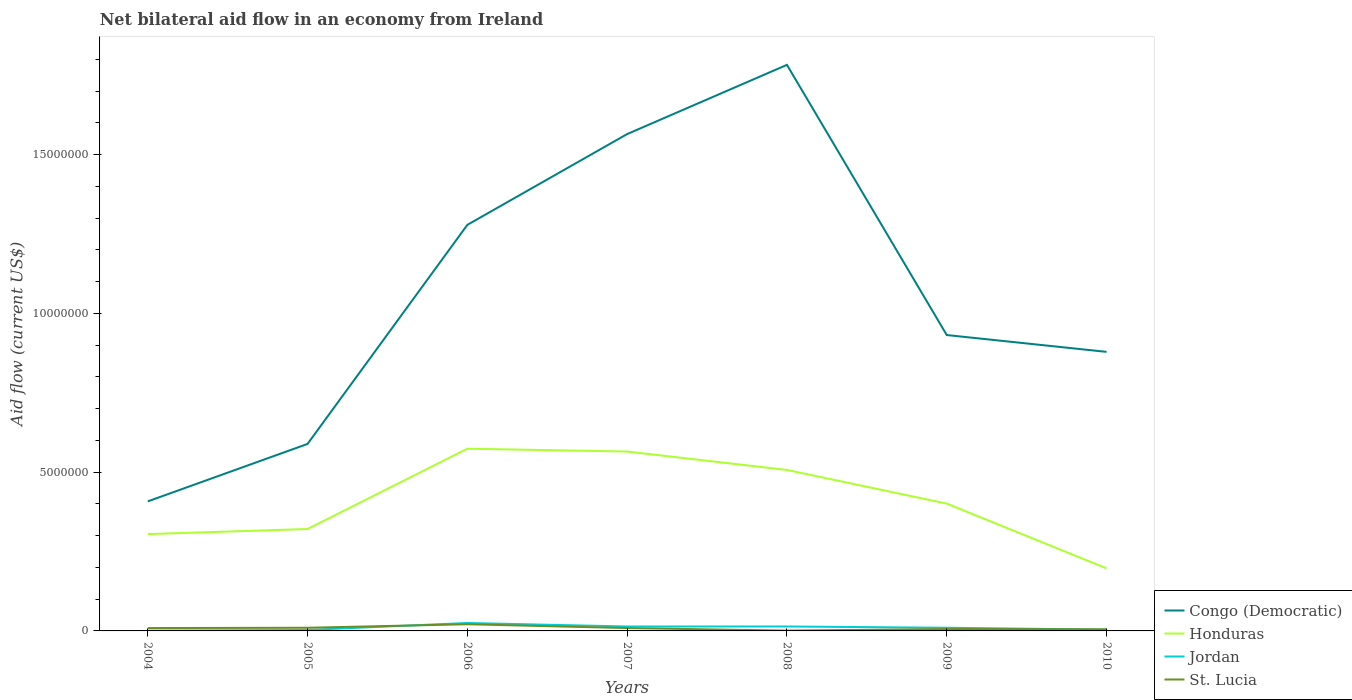Is the number of lines equal to the number of legend labels?
Keep it short and to the point. Yes. Across all years, what is the maximum net bilateral aid flow in Congo (Democratic)?
Provide a short and direct response. 4.08e+06. In which year was the net bilateral aid flow in Congo (Democratic) maximum?
Offer a very short reply. 2004. Is the net bilateral aid flow in Congo (Democratic) strictly greater than the net bilateral aid flow in St. Lucia over the years?
Your answer should be very brief. No. How many lines are there?
Make the answer very short. 4. What is the difference between two consecutive major ticks on the Y-axis?
Provide a short and direct response. 5.00e+06. Does the graph contain any zero values?
Offer a very short reply. No. Does the graph contain grids?
Provide a succinct answer. No. What is the title of the graph?
Keep it short and to the point. Net bilateral aid flow in an economy from Ireland. What is the label or title of the X-axis?
Keep it short and to the point. Years. What is the label or title of the Y-axis?
Offer a very short reply. Aid flow (current US$). What is the Aid flow (current US$) of Congo (Democratic) in 2004?
Make the answer very short. 4.08e+06. What is the Aid flow (current US$) in Honduras in 2004?
Your answer should be compact. 3.05e+06. What is the Aid flow (current US$) of Jordan in 2004?
Your response must be concise. 10000. What is the Aid flow (current US$) in St. Lucia in 2004?
Keep it short and to the point. 9.00e+04. What is the Aid flow (current US$) in Congo (Democratic) in 2005?
Ensure brevity in your answer.  5.89e+06. What is the Aid flow (current US$) of Honduras in 2005?
Keep it short and to the point. 3.21e+06. What is the Aid flow (current US$) in Jordan in 2005?
Provide a short and direct response. 3.00e+04. What is the Aid flow (current US$) of St. Lucia in 2005?
Ensure brevity in your answer.  1.00e+05. What is the Aid flow (current US$) in Congo (Democratic) in 2006?
Offer a very short reply. 1.28e+07. What is the Aid flow (current US$) in Honduras in 2006?
Keep it short and to the point. 5.74e+06. What is the Aid flow (current US$) of St. Lucia in 2006?
Provide a short and direct response. 2.10e+05. What is the Aid flow (current US$) in Congo (Democratic) in 2007?
Offer a very short reply. 1.56e+07. What is the Aid flow (current US$) in Honduras in 2007?
Provide a short and direct response. 5.65e+06. What is the Aid flow (current US$) in Congo (Democratic) in 2008?
Offer a terse response. 1.78e+07. What is the Aid flow (current US$) of Honduras in 2008?
Your response must be concise. 5.07e+06. What is the Aid flow (current US$) of Jordan in 2008?
Your answer should be very brief. 1.40e+05. What is the Aid flow (current US$) in St. Lucia in 2008?
Offer a very short reply. 10000. What is the Aid flow (current US$) of Congo (Democratic) in 2009?
Give a very brief answer. 9.32e+06. What is the Aid flow (current US$) in Honduras in 2009?
Offer a very short reply. 4.01e+06. What is the Aid flow (current US$) of Congo (Democratic) in 2010?
Ensure brevity in your answer.  8.79e+06. What is the Aid flow (current US$) of Honduras in 2010?
Your answer should be compact. 1.97e+06. What is the Aid flow (current US$) of St. Lucia in 2010?
Offer a terse response. 5.00e+04. Across all years, what is the maximum Aid flow (current US$) of Congo (Democratic)?
Ensure brevity in your answer.  1.78e+07. Across all years, what is the maximum Aid flow (current US$) of Honduras?
Ensure brevity in your answer.  5.74e+06. Across all years, what is the minimum Aid flow (current US$) in Congo (Democratic)?
Provide a succinct answer. 4.08e+06. Across all years, what is the minimum Aid flow (current US$) of Honduras?
Offer a terse response. 1.97e+06. Across all years, what is the minimum Aid flow (current US$) in Jordan?
Make the answer very short. 10000. Across all years, what is the minimum Aid flow (current US$) in St. Lucia?
Provide a succinct answer. 10000. What is the total Aid flow (current US$) in Congo (Democratic) in the graph?
Make the answer very short. 7.44e+07. What is the total Aid flow (current US$) of Honduras in the graph?
Give a very brief answer. 2.87e+07. What is the total Aid flow (current US$) of Jordan in the graph?
Your answer should be very brief. 7.10e+05. What is the total Aid flow (current US$) of St. Lucia in the graph?
Your answer should be compact. 6.10e+05. What is the difference between the Aid flow (current US$) of Congo (Democratic) in 2004 and that in 2005?
Give a very brief answer. -1.81e+06. What is the difference between the Aid flow (current US$) of Jordan in 2004 and that in 2005?
Your answer should be very brief. -2.00e+04. What is the difference between the Aid flow (current US$) in St. Lucia in 2004 and that in 2005?
Make the answer very short. -10000. What is the difference between the Aid flow (current US$) in Congo (Democratic) in 2004 and that in 2006?
Keep it short and to the point. -8.71e+06. What is the difference between the Aid flow (current US$) of Honduras in 2004 and that in 2006?
Offer a terse response. -2.69e+06. What is the difference between the Aid flow (current US$) of Jordan in 2004 and that in 2006?
Offer a terse response. -2.40e+05. What is the difference between the Aid flow (current US$) in Congo (Democratic) in 2004 and that in 2007?
Make the answer very short. -1.16e+07. What is the difference between the Aid flow (current US$) in Honduras in 2004 and that in 2007?
Offer a terse response. -2.60e+06. What is the difference between the Aid flow (current US$) in Jordan in 2004 and that in 2007?
Make the answer very short. -1.30e+05. What is the difference between the Aid flow (current US$) of Congo (Democratic) in 2004 and that in 2008?
Provide a succinct answer. -1.38e+07. What is the difference between the Aid flow (current US$) of Honduras in 2004 and that in 2008?
Provide a short and direct response. -2.02e+06. What is the difference between the Aid flow (current US$) in Jordan in 2004 and that in 2008?
Your answer should be very brief. -1.30e+05. What is the difference between the Aid flow (current US$) of St. Lucia in 2004 and that in 2008?
Your answer should be very brief. 8.00e+04. What is the difference between the Aid flow (current US$) in Congo (Democratic) in 2004 and that in 2009?
Ensure brevity in your answer.  -5.24e+06. What is the difference between the Aid flow (current US$) of Honduras in 2004 and that in 2009?
Your answer should be compact. -9.60e+05. What is the difference between the Aid flow (current US$) of Congo (Democratic) in 2004 and that in 2010?
Offer a terse response. -4.71e+06. What is the difference between the Aid flow (current US$) in Honduras in 2004 and that in 2010?
Offer a terse response. 1.08e+06. What is the difference between the Aid flow (current US$) of Congo (Democratic) in 2005 and that in 2006?
Your answer should be very brief. -6.90e+06. What is the difference between the Aid flow (current US$) in Honduras in 2005 and that in 2006?
Ensure brevity in your answer.  -2.53e+06. What is the difference between the Aid flow (current US$) in Congo (Democratic) in 2005 and that in 2007?
Offer a terse response. -9.76e+06. What is the difference between the Aid flow (current US$) of Honduras in 2005 and that in 2007?
Your answer should be compact. -2.44e+06. What is the difference between the Aid flow (current US$) in St. Lucia in 2005 and that in 2007?
Your response must be concise. 10000. What is the difference between the Aid flow (current US$) of Congo (Democratic) in 2005 and that in 2008?
Provide a succinct answer. -1.19e+07. What is the difference between the Aid flow (current US$) of Honduras in 2005 and that in 2008?
Give a very brief answer. -1.86e+06. What is the difference between the Aid flow (current US$) of Congo (Democratic) in 2005 and that in 2009?
Provide a succinct answer. -3.43e+06. What is the difference between the Aid flow (current US$) in Honduras in 2005 and that in 2009?
Ensure brevity in your answer.  -8.00e+05. What is the difference between the Aid flow (current US$) of Jordan in 2005 and that in 2009?
Provide a short and direct response. -7.00e+04. What is the difference between the Aid flow (current US$) of Congo (Democratic) in 2005 and that in 2010?
Your response must be concise. -2.90e+06. What is the difference between the Aid flow (current US$) of Honduras in 2005 and that in 2010?
Keep it short and to the point. 1.24e+06. What is the difference between the Aid flow (current US$) in Jordan in 2005 and that in 2010?
Make the answer very short. -10000. What is the difference between the Aid flow (current US$) of St. Lucia in 2005 and that in 2010?
Offer a very short reply. 5.00e+04. What is the difference between the Aid flow (current US$) of Congo (Democratic) in 2006 and that in 2007?
Your answer should be compact. -2.86e+06. What is the difference between the Aid flow (current US$) of Honduras in 2006 and that in 2007?
Your response must be concise. 9.00e+04. What is the difference between the Aid flow (current US$) in St. Lucia in 2006 and that in 2007?
Ensure brevity in your answer.  1.20e+05. What is the difference between the Aid flow (current US$) of Congo (Democratic) in 2006 and that in 2008?
Your answer should be very brief. -5.04e+06. What is the difference between the Aid flow (current US$) in Honduras in 2006 and that in 2008?
Offer a terse response. 6.70e+05. What is the difference between the Aid flow (current US$) in Congo (Democratic) in 2006 and that in 2009?
Your response must be concise. 3.47e+06. What is the difference between the Aid flow (current US$) in Honduras in 2006 and that in 2009?
Offer a very short reply. 1.73e+06. What is the difference between the Aid flow (current US$) in Honduras in 2006 and that in 2010?
Ensure brevity in your answer.  3.77e+06. What is the difference between the Aid flow (current US$) in Jordan in 2006 and that in 2010?
Your answer should be very brief. 2.10e+05. What is the difference between the Aid flow (current US$) in Congo (Democratic) in 2007 and that in 2008?
Offer a very short reply. -2.18e+06. What is the difference between the Aid flow (current US$) of Honduras in 2007 and that in 2008?
Ensure brevity in your answer.  5.80e+05. What is the difference between the Aid flow (current US$) in St. Lucia in 2007 and that in 2008?
Your answer should be compact. 8.00e+04. What is the difference between the Aid flow (current US$) of Congo (Democratic) in 2007 and that in 2009?
Your response must be concise. 6.33e+06. What is the difference between the Aid flow (current US$) in Honduras in 2007 and that in 2009?
Offer a very short reply. 1.64e+06. What is the difference between the Aid flow (current US$) of St. Lucia in 2007 and that in 2009?
Your answer should be compact. 3.00e+04. What is the difference between the Aid flow (current US$) of Congo (Democratic) in 2007 and that in 2010?
Offer a very short reply. 6.86e+06. What is the difference between the Aid flow (current US$) of Honduras in 2007 and that in 2010?
Offer a very short reply. 3.68e+06. What is the difference between the Aid flow (current US$) of Congo (Democratic) in 2008 and that in 2009?
Your answer should be very brief. 8.51e+06. What is the difference between the Aid flow (current US$) in Honduras in 2008 and that in 2009?
Give a very brief answer. 1.06e+06. What is the difference between the Aid flow (current US$) of Congo (Democratic) in 2008 and that in 2010?
Provide a succinct answer. 9.04e+06. What is the difference between the Aid flow (current US$) in Honduras in 2008 and that in 2010?
Give a very brief answer. 3.10e+06. What is the difference between the Aid flow (current US$) in Jordan in 2008 and that in 2010?
Your answer should be very brief. 1.00e+05. What is the difference between the Aid flow (current US$) in St. Lucia in 2008 and that in 2010?
Provide a succinct answer. -4.00e+04. What is the difference between the Aid flow (current US$) in Congo (Democratic) in 2009 and that in 2010?
Offer a terse response. 5.30e+05. What is the difference between the Aid flow (current US$) in Honduras in 2009 and that in 2010?
Provide a short and direct response. 2.04e+06. What is the difference between the Aid flow (current US$) of Jordan in 2009 and that in 2010?
Offer a very short reply. 6.00e+04. What is the difference between the Aid flow (current US$) of St. Lucia in 2009 and that in 2010?
Keep it short and to the point. 10000. What is the difference between the Aid flow (current US$) of Congo (Democratic) in 2004 and the Aid flow (current US$) of Honduras in 2005?
Ensure brevity in your answer.  8.70e+05. What is the difference between the Aid flow (current US$) of Congo (Democratic) in 2004 and the Aid flow (current US$) of Jordan in 2005?
Your answer should be very brief. 4.05e+06. What is the difference between the Aid flow (current US$) of Congo (Democratic) in 2004 and the Aid flow (current US$) of St. Lucia in 2005?
Your answer should be compact. 3.98e+06. What is the difference between the Aid flow (current US$) of Honduras in 2004 and the Aid flow (current US$) of Jordan in 2005?
Offer a very short reply. 3.02e+06. What is the difference between the Aid flow (current US$) in Honduras in 2004 and the Aid flow (current US$) in St. Lucia in 2005?
Offer a very short reply. 2.95e+06. What is the difference between the Aid flow (current US$) of Congo (Democratic) in 2004 and the Aid flow (current US$) of Honduras in 2006?
Your answer should be very brief. -1.66e+06. What is the difference between the Aid flow (current US$) of Congo (Democratic) in 2004 and the Aid flow (current US$) of Jordan in 2006?
Ensure brevity in your answer.  3.83e+06. What is the difference between the Aid flow (current US$) in Congo (Democratic) in 2004 and the Aid flow (current US$) in St. Lucia in 2006?
Provide a succinct answer. 3.87e+06. What is the difference between the Aid flow (current US$) in Honduras in 2004 and the Aid flow (current US$) in Jordan in 2006?
Offer a very short reply. 2.80e+06. What is the difference between the Aid flow (current US$) in Honduras in 2004 and the Aid flow (current US$) in St. Lucia in 2006?
Your answer should be very brief. 2.84e+06. What is the difference between the Aid flow (current US$) in Jordan in 2004 and the Aid flow (current US$) in St. Lucia in 2006?
Ensure brevity in your answer.  -2.00e+05. What is the difference between the Aid flow (current US$) of Congo (Democratic) in 2004 and the Aid flow (current US$) of Honduras in 2007?
Your answer should be very brief. -1.57e+06. What is the difference between the Aid flow (current US$) in Congo (Democratic) in 2004 and the Aid flow (current US$) in Jordan in 2007?
Ensure brevity in your answer.  3.94e+06. What is the difference between the Aid flow (current US$) in Congo (Democratic) in 2004 and the Aid flow (current US$) in St. Lucia in 2007?
Provide a short and direct response. 3.99e+06. What is the difference between the Aid flow (current US$) of Honduras in 2004 and the Aid flow (current US$) of Jordan in 2007?
Your response must be concise. 2.91e+06. What is the difference between the Aid flow (current US$) of Honduras in 2004 and the Aid flow (current US$) of St. Lucia in 2007?
Give a very brief answer. 2.96e+06. What is the difference between the Aid flow (current US$) in Congo (Democratic) in 2004 and the Aid flow (current US$) in Honduras in 2008?
Ensure brevity in your answer.  -9.90e+05. What is the difference between the Aid flow (current US$) of Congo (Democratic) in 2004 and the Aid flow (current US$) of Jordan in 2008?
Your answer should be very brief. 3.94e+06. What is the difference between the Aid flow (current US$) of Congo (Democratic) in 2004 and the Aid flow (current US$) of St. Lucia in 2008?
Provide a short and direct response. 4.07e+06. What is the difference between the Aid flow (current US$) of Honduras in 2004 and the Aid flow (current US$) of Jordan in 2008?
Make the answer very short. 2.91e+06. What is the difference between the Aid flow (current US$) of Honduras in 2004 and the Aid flow (current US$) of St. Lucia in 2008?
Ensure brevity in your answer.  3.04e+06. What is the difference between the Aid flow (current US$) in Jordan in 2004 and the Aid flow (current US$) in St. Lucia in 2008?
Provide a succinct answer. 0. What is the difference between the Aid flow (current US$) in Congo (Democratic) in 2004 and the Aid flow (current US$) in Jordan in 2009?
Make the answer very short. 3.98e+06. What is the difference between the Aid flow (current US$) in Congo (Democratic) in 2004 and the Aid flow (current US$) in St. Lucia in 2009?
Provide a succinct answer. 4.02e+06. What is the difference between the Aid flow (current US$) in Honduras in 2004 and the Aid flow (current US$) in Jordan in 2009?
Offer a very short reply. 2.95e+06. What is the difference between the Aid flow (current US$) in Honduras in 2004 and the Aid flow (current US$) in St. Lucia in 2009?
Provide a short and direct response. 2.99e+06. What is the difference between the Aid flow (current US$) of Jordan in 2004 and the Aid flow (current US$) of St. Lucia in 2009?
Make the answer very short. -5.00e+04. What is the difference between the Aid flow (current US$) of Congo (Democratic) in 2004 and the Aid flow (current US$) of Honduras in 2010?
Ensure brevity in your answer.  2.11e+06. What is the difference between the Aid flow (current US$) of Congo (Democratic) in 2004 and the Aid flow (current US$) of Jordan in 2010?
Your response must be concise. 4.04e+06. What is the difference between the Aid flow (current US$) in Congo (Democratic) in 2004 and the Aid flow (current US$) in St. Lucia in 2010?
Offer a terse response. 4.03e+06. What is the difference between the Aid flow (current US$) in Honduras in 2004 and the Aid flow (current US$) in Jordan in 2010?
Ensure brevity in your answer.  3.01e+06. What is the difference between the Aid flow (current US$) in Honduras in 2004 and the Aid flow (current US$) in St. Lucia in 2010?
Your answer should be compact. 3.00e+06. What is the difference between the Aid flow (current US$) of Congo (Democratic) in 2005 and the Aid flow (current US$) of Jordan in 2006?
Your response must be concise. 5.64e+06. What is the difference between the Aid flow (current US$) of Congo (Democratic) in 2005 and the Aid flow (current US$) of St. Lucia in 2006?
Keep it short and to the point. 5.68e+06. What is the difference between the Aid flow (current US$) of Honduras in 2005 and the Aid flow (current US$) of Jordan in 2006?
Offer a terse response. 2.96e+06. What is the difference between the Aid flow (current US$) in Honduras in 2005 and the Aid flow (current US$) in St. Lucia in 2006?
Keep it short and to the point. 3.00e+06. What is the difference between the Aid flow (current US$) of Jordan in 2005 and the Aid flow (current US$) of St. Lucia in 2006?
Provide a succinct answer. -1.80e+05. What is the difference between the Aid flow (current US$) of Congo (Democratic) in 2005 and the Aid flow (current US$) of Honduras in 2007?
Provide a succinct answer. 2.40e+05. What is the difference between the Aid flow (current US$) in Congo (Democratic) in 2005 and the Aid flow (current US$) in Jordan in 2007?
Offer a terse response. 5.75e+06. What is the difference between the Aid flow (current US$) in Congo (Democratic) in 2005 and the Aid flow (current US$) in St. Lucia in 2007?
Offer a very short reply. 5.80e+06. What is the difference between the Aid flow (current US$) in Honduras in 2005 and the Aid flow (current US$) in Jordan in 2007?
Make the answer very short. 3.07e+06. What is the difference between the Aid flow (current US$) in Honduras in 2005 and the Aid flow (current US$) in St. Lucia in 2007?
Make the answer very short. 3.12e+06. What is the difference between the Aid flow (current US$) of Congo (Democratic) in 2005 and the Aid flow (current US$) of Honduras in 2008?
Provide a succinct answer. 8.20e+05. What is the difference between the Aid flow (current US$) of Congo (Democratic) in 2005 and the Aid flow (current US$) of Jordan in 2008?
Your answer should be very brief. 5.75e+06. What is the difference between the Aid flow (current US$) of Congo (Democratic) in 2005 and the Aid flow (current US$) of St. Lucia in 2008?
Give a very brief answer. 5.88e+06. What is the difference between the Aid flow (current US$) of Honduras in 2005 and the Aid flow (current US$) of Jordan in 2008?
Your answer should be very brief. 3.07e+06. What is the difference between the Aid flow (current US$) in Honduras in 2005 and the Aid flow (current US$) in St. Lucia in 2008?
Provide a succinct answer. 3.20e+06. What is the difference between the Aid flow (current US$) of Congo (Democratic) in 2005 and the Aid flow (current US$) of Honduras in 2009?
Provide a succinct answer. 1.88e+06. What is the difference between the Aid flow (current US$) of Congo (Democratic) in 2005 and the Aid flow (current US$) of Jordan in 2009?
Your answer should be compact. 5.79e+06. What is the difference between the Aid flow (current US$) of Congo (Democratic) in 2005 and the Aid flow (current US$) of St. Lucia in 2009?
Offer a very short reply. 5.83e+06. What is the difference between the Aid flow (current US$) of Honduras in 2005 and the Aid flow (current US$) of Jordan in 2009?
Provide a succinct answer. 3.11e+06. What is the difference between the Aid flow (current US$) of Honduras in 2005 and the Aid flow (current US$) of St. Lucia in 2009?
Give a very brief answer. 3.15e+06. What is the difference between the Aid flow (current US$) of Congo (Democratic) in 2005 and the Aid flow (current US$) of Honduras in 2010?
Your answer should be very brief. 3.92e+06. What is the difference between the Aid flow (current US$) in Congo (Democratic) in 2005 and the Aid flow (current US$) in Jordan in 2010?
Make the answer very short. 5.85e+06. What is the difference between the Aid flow (current US$) of Congo (Democratic) in 2005 and the Aid flow (current US$) of St. Lucia in 2010?
Your response must be concise. 5.84e+06. What is the difference between the Aid flow (current US$) of Honduras in 2005 and the Aid flow (current US$) of Jordan in 2010?
Your answer should be very brief. 3.17e+06. What is the difference between the Aid flow (current US$) in Honduras in 2005 and the Aid flow (current US$) in St. Lucia in 2010?
Give a very brief answer. 3.16e+06. What is the difference between the Aid flow (current US$) in Congo (Democratic) in 2006 and the Aid flow (current US$) in Honduras in 2007?
Give a very brief answer. 7.14e+06. What is the difference between the Aid flow (current US$) of Congo (Democratic) in 2006 and the Aid flow (current US$) of Jordan in 2007?
Make the answer very short. 1.26e+07. What is the difference between the Aid flow (current US$) in Congo (Democratic) in 2006 and the Aid flow (current US$) in St. Lucia in 2007?
Keep it short and to the point. 1.27e+07. What is the difference between the Aid flow (current US$) in Honduras in 2006 and the Aid flow (current US$) in Jordan in 2007?
Keep it short and to the point. 5.60e+06. What is the difference between the Aid flow (current US$) in Honduras in 2006 and the Aid flow (current US$) in St. Lucia in 2007?
Your response must be concise. 5.65e+06. What is the difference between the Aid flow (current US$) in Congo (Democratic) in 2006 and the Aid flow (current US$) in Honduras in 2008?
Provide a short and direct response. 7.72e+06. What is the difference between the Aid flow (current US$) of Congo (Democratic) in 2006 and the Aid flow (current US$) of Jordan in 2008?
Your answer should be very brief. 1.26e+07. What is the difference between the Aid flow (current US$) of Congo (Democratic) in 2006 and the Aid flow (current US$) of St. Lucia in 2008?
Your response must be concise. 1.28e+07. What is the difference between the Aid flow (current US$) of Honduras in 2006 and the Aid flow (current US$) of Jordan in 2008?
Your response must be concise. 5.60e+06. What is the difference between the Aid flow (current US$) of Honduras in 2006 and the Aid flow (current US$) of St. Lucia in 2008?
Ensure brevity in your answer.  5.73e+06. What is the difference between the Aid flow (current US$) in Congo (Democratic) in 2006 and the Aid flow (current US$) in Honduras in 2009?
Your answer should be compact. 8.78e+06. What is the difference between the Aid flow (current US$) of Congo (Democratic) in 2006 and the Aid flow (current US$) of Jordan in 2009?
Provide a succinct answer. 1.27e+07. What is the difference between the Aid flow (current US$) in Congo (Democratic) in 2006 and the Aid flow (current US$) in St. Lucia in 2009?
Offer a very short reply. 1.27e+07. What is the difference between the Aid flow (current US$) of Honduras in 2006 and the Aid flow (current US$) of Jordan in 2009?
Provide a succinct answer. 5.64e+06. What is the difference between the Aid flow (current US$) in Honduras in 2006 and the Aid flow (current US$) in St. Lucia in 2009?
Keep it short and to the point. 5.68e+06. What is the difference between the Aid flow (current US$) of Jordan in 2006 and the Aid flow (current US$) of St. Lucia in 2009?
Offer a very short reply. 1.90e+05. What is the difference between the Aid flow (current US$) in Congo (Democratic) in 2006 and the Aid flow (current US$) in Honduras in 2010?
Make the answer very short. 1.08e+07. What is the difference between the Aid flow (current US$) of Congo (Democratic) in 2006 and the Aid flow (current US$) of Jordan in 2010?
Make the answer very short. 1.28e+07. What is the difference between the Aid flow (current US$) in Congo (Democratic) in 2006 and the Aid flow (current US$) in St. Lucia in 2010?
Your response must be concise. 1.27e+07. What is the difference between the Aid flow (current US$) of Honduras in 2006 and the Aid flow (current US$) of Jordan in 2010?
Your answer should be compact. 5.70e+06. What is the difference between the Aid flow (current US$) of Honduras in 2006 and the Aid flow (current US$) of St. Lucia in 2010?
Keep it short and to the point. 5.69e+06. What is the difference between the Aid flow (current US$) in Congo (Democratic) in 2007 and the Aid flow (current US$) in Honduras in 2008?
Provide a succinct answer. 1.06e+07. What is the difference between the Aid flow (current US$) in Congo (Democratic) in 2007 and the Aid flow (current US$) in Jordan in 2008?
Give a very brief answer. 1.55e+07. What is the difference between the Aid flow (current US$) of Congo (Democratic) in 2007 and the Aid flow (current US$) of St. Lucia in 2008?
Make the answer very short. 1.56e+07. What is the difference between the Aid flow (current US$) of Honduras in 2007 and the Aid flow (current US$) of Jordan in 2008?
Provide a succinct answer. 5.51e+06. What is the difference between the Aid flow (current US$) in Honduras in 2007 and the Aid flow (current US$) in St. Lucia in 2008?
Provide a short and direct response. 5.64e+06. What is the difference between the Aid flow (current US$) in Congo (Democratic) in 2007 and the Aid flow (current US$) in Honduras in 2009?
Your response must be concise. 1.16e+07. What is the difference between the Aid flow (current US$) in Congo (Democratic) in 2007 and the Aid flow (current US$) in Jordan in 2009?
Offer a very short reply. 1.56e+07. What is the difference between the Aid flow (current US$) of Congo (Democratic) in 2007 and the Aid flow (current US$) of St. Lucia in 2009?
Your answer should be compact. 1.56e+07. What is the difference between the Aid flow (current US$) in Honduras in 2007 and the Aid flow (current US$) in Jordan in 2009?
Keep it short and to the point. 5.55e+06. What is the difference between the Aid flow (current US$) in Honduras in 2007 and the Aid flow (current US$) in St. Lucia in 2009?
Offer a very short reply. 5.59e+06. What is the difference between the Aid flow (current US$) in Jordan in 2007 and the Aid flow (current US$) in St. Lucia in 2009?
Give a very brief answer. 8.00e+04. What is the difference between the Aid flow (current US$) of Congo (Democratic) in 2007 and the Aid flow (current US$) of Honduras in 2010?
Provide a succinct answer. 1.37e+07. What is the difference between the Aid flow (current US$) of Congo (Democratic) in 2007 and the Aid flow (current US$) of Jordan in 2010?
Give a very brief answer. 1.56e+07. What is the difference between the Aid flow (current US$) in Congo (Democratic) in 2007 and the Aid flow (current US$) in St. Lucia in 2010?
Provide a succinct answer. 1.56e+07. What is the difference between the Aid flow (current US$) of Honduras in 2007 and the Aid flow (current US$) of Jordan in 2010?
Give a very brief answer. 5.61e+06. What is the difference between the Aid flow (current US$) of Honduras in 2007 and the Aid flow (current US$) of St. Lucia in 2010?
Your answer should be compact. 5.60e+06. What is the difference between the Aid flow (current US$) of Congo (Democratic) in 2008 and the Aid flow (current US$) of Honduras in 2009?
Offer a very short reply. 1.38e+07. What is the difference between the Aid flow (current US$) in Congo (Democratic) in 2008 and the Aid flow (current US$) in Jordan in 2009?
Ensure brevity in your answer.  1.77e+07. What is the difference between the Aid flow (current US$) in Congo (Democratic) in 2008 and the Aid flow (current US$) in St. Lucia in 2009?
Offer a terse response. 1.78e+07. What is the difference between the Aid flow (current US$) of Honduras in 2008 and the Aid flow (current US$) of Jordan in 2009?
Give a very brief answer. 4.97e+06. What is the difference between the Aid flow (current US$) in Honduras in 2008 and the Aid flow (current US$) in St. Lucia in 2009?
Provide a succinct answer. 5.01e+06. What is the difference between the Aid flow (current US$) of Congo (Democratic) in 2008 and the Aid flow (current US$) of Honduras in 2010?
Your answer should be compact. 1.59e+07. What is the difference between the Aid flow (current US$) of Congo (Democratic) in 2008 and the Aid flow (current US$) of Jordan in 2010?
Provide a short and direct response. 1.78e+07. What is the difference between the Aid flow (current US$) of Congo (Democratic) in 2008 and the Aid flow (current US$) of St. Lucia in 2010?
Give a very brief answer. 1.78e+07. What is the difference between the Aid flow (current US$) in Honduras in 2008 and the Aid flow (current US$) in Jordan in 2010?
Offer a terse response. 5.03e+06. What is the difference between the Aid flow (current US$) of Honduras in 2008 and the Aid flow (current US$) of St. Lucia in 2010?
Provide a succinct answer. 5.02e+06. What is the difference between the Aid flow (current US$) in Jordan in 2008 and the Aid flow (current US$) in St. Lucia in 2010?
Your response must be concise. 9.00e+04. What is the difference between the Aid flow (current US$) of Congo (Democratic) in 2009 and the Aid flow (current US$) of Honduras in 2010?
Make the answer very short. 7.35e+06. What is the difference between the Aid flow (current US$) of Congo (Democratic) in 2009 and the Aid flow (current US$) of Jordan in 2010?
Give a very brief answer. 9.28e+06. What is the difference between the Aid flow (current US$) of Congo (Democratic) in 2009 and the Aid flow (current US$) of St. Lucia in 2010?
Offer a very short reply. 9.27e+06. What is the difference between the Aid flow (current US$) of Honduras in 2009 and the Aid flow (current US$) of Jordan in 2010?
Offer a terse response. 3.97e+06. What is the difference between the Aid flow (current US$) of Honduras in 2009 and the Aid flow (current US$) of St. Lucia in 2010?
Offer a very short reply. 3.96e+06. What is the difference between the Aid flow (current US$) in Jordan in 2009 and the Aid flow (current US$) in St. Lucia in 2010?
Your answer should be compact. 5.00e+04. What is the average Aid flow (current US$) in Congo (Democratic) per year?
Provide a short and direct response. 1.06e+07. What is the average Aid flow (current US$) in Honduras per year?
Make the answer very short. 4.10e+06. What is the average Aid flow (current US$) in Jordan per year?
Your answer should be compact. 1.01e+05. What is the average Aid flow (current US$) in St. Lucia per year?
Provide a succinct answer. 8.71e+04. In the year 2004, what is the difference between the Aid flow (current US$) of Congo (Democratic) and Aid flow (current US$) of Honduras?
Give a very brief answer. 1.03e+06. In the year 2004, what is the difference between the Aid flow (current US$) of Congo (Democratic) and Aid flow (current US$) of Jordan?
Keep it short and to the point. 4.07e+06. In the year 2004, what is the difference between the Aid flow (current US$) of Congo (Democratic) and Aid flow (current US$) of St. Lucia?
Your response must be concise. 3.99e+06. In the year 2004, what is the difference between the Aid flow (current US$) in Honduras and Aid flow (current US$) in Jordan?
Make the answer very short. 3.04e+06. In the year 2004, what is the difference between the Aid flow (current US$) in Honduras and Aid flow (current US$) in St. Lucia?
Make the answer very short. 2.96e+06. In the year 2004, what is the difference between the Aid flow (current US$) of Jordan and Aid flow (current US$) of St. Lucia?
Provide a succinct answer. -8.00e+04. In the year 2005, what is the difference between the Aid flow (current US$) in Congo (Democratic) and Aid flow (current US$) in Honduras?
Provide a succinct answer. 2.68e+06. In the year 2005, what is the difference between the Aid flow (current US$) in Congo (Democratic) and Aid flow (current US$) in Jordan?
Give a very brief answer. 5.86e+06. In the year 2005, what is the difference between the Aid flow (current US$) of Congo (Democratic) and Aid flow (current US$) of St. Lucia?
Make the answer very short. 5.79e+06. In the year 2005, what is the difference between the Aid flow (current US$) of Honduras and Aid flow (current US$) of Jordan?
Provide a short and direct response. 3.18e+06. In the year 2005, what is the difference between the Aid flow (current US$) of Honduras and Aid flow (current US$) of St. Lucia?
Your response must be concise. 3.11e+06. In the year 2006, what is the difference between the Aid flow (current US$) in Congo (Democratic) and Aid flow (current US$) in Honduras?
Make the answer very short. 7.05e+06. In the year 2006, what is the difference between the Aid flow (current US$) in Congo (Democratic) and Aid flow (current US$) in Jordan?
Provide a succinct answer. 1.25e+07. In the year 2006, what is the difference between the Aid flow (current US$) in Congo (Democratic) and Aid flow (current US$) in St. Lucia?
Your answer should be very brief. 1.26e+07. In the year 2006, what is the difference between the Aid flow (current US$) in Honduras and Aid flow (current US$) in Jordan?
Give a very brief answer. 5.49e+06. In the year 2006, what is the difference between the Aid flow (current US$) in Honduras and Aid flow (current US$) in St. Lucia?
Give a very brief answer. 5.53e+06. In the year 2006, what is the difference between the Aid flow (current US$) of Jordan and Aid flow (current US$) of St. Lucia?
Keep it short and to the point. 4.00e+04. In the year 2007, what is the difference between the Aid flow (current US$) in Congo (Democratic) and Aid flow (current US$) in Honduras?
Make the answer very short. 1.00e+07. In the year 2007, what is the difference between the Aid flow (current US$) in Congo (Democratic) and Aid flow (current US$) in Jordan?
Offer a very short reply. 1.55e+07. In the year 2007, what is the difference between the Aid flow (current US$) in Congo (Democratic) and Aid flow (current US$) in St. Lucia?
Your answer should be very brief. 1.56e+07. In the year 2007, what is the difference between the Aid flow (current US$) in Honduras and Aid flow (current US$) in Jordan?
Provide a short and direct response. 5.51e+06. In the year 2007, what is the difference between the Aid flow (current US$) of Honduras and Aid flow (current US$) of St. Lucia?
Make the answer very short. 5.56e+06. In the year 2008, what is the difference between the Aid flow (current US$) of Congo (Democratic) and Aid flow (current US$) of Honduras?
Keep it short and to the point. 1.28e+07. In the year 2008, what is the difference between the Aid flow (current US$) in Congo (Democratic) and Aid flow (current US$) in Jordan?
Keep it short and to the point. 1.77e+07. In the year 2008, what is the difference between the Aid flow (current US$) in Congo (Democratic) and Aid flow (current US$) in St. Lucia?
Your answer should be very brief. 1.78e+07. In the year 2008, what is the difference between the Aid flow (current US$) in Honduras and Aid flow (current US$) in Jordan?
Provide a short and direct response. 4.93e+06. In the year 2008, what is the difference between the Aid flow (current US$) in Honduras and Aid flow (current US$) in St. Lucia?
Keep it short and to the point. 5.06e+06. In the year 2009, what is the difference between the Aid flow (current US$) of Congo (Democratic) and Aid flow (current US$) of Honduras?
Ensure brevity in your answer.  5.31e+06. In the year 2009, what is the difference between the Aid flow (current US$) in Congo (Democratic) and Aid flow (current US$) in Jordan?
Keep it short and to the point. 9.22e+06. In the year 2009, what is the difference between the Aid flow (current US$) in Congo (Democratic) and Aid flow (current US$) in St. Lucia?
Your response must be concise. 9.26e+06. In the year 2009, what is the difference between the Aid flow (current US$) in Honduras and Aid flow (current US$) in Jordan?
Your response must be concise. 3.91e+06. In the year 2009, what is the difference between the Aid flow (current US$) in Honduras and Aid flow (current US$) in St. Lucia?
Make the answer very short. 3.95e+06. In the year 2009, what is the difference between the Aid flow (current US$) of Jordan and Aid flow (current US$) of St. Lucia?
Give a very brief answer. 4.00e+04. In the year 2010, what is the difference between the Aid flow (current US$) in Congo (Democratic) and Aid flow (current US$) in Honduras?
Provide a succinct answer. 6.82e+06. In the year 2010, what is the difference between the Aid flow (current US$) in Congo (Democratic) and Aid flow (current US$) in Jordan?
Offer a very short reply. 8.75e+06. In the year 2010, what is the difference between the Aid flow (current US$) in Congo (Democratic) and Aid flow (current US$) in St. Lucia?
Your response must be concise. 8.74e+06. In the year 2010, what is the difference between the Aid flow (current US$) in Honduras and Aid flow (current US$) in Jordan?
Keep it short and to the point. 1.93e+06. In the year 2010, what is the difference between the Aid flow (current US$) in Honduras and Aid flow (current US$) in St. Lucia?
Your answer should be very brief. 1.92e+06. In the year 2010, what is the difference between the Aid flow (current US$) in Jordan and Aid flow (current US$) in St. Lucia?
Your answer should be compact. -10000. What is the ratio of the Aid flow (current US$) of Congo (Democratic) in 2004 to that in 2005?
Keep it short and to the point. 0.69. What is the ratio of the Aid flow (current US$) of Honduras in 2004 to that in 2005?
Give a very brief answer. 0.95. What is the ratio of the Aid flow (current US$) in Congo (Democratic) in 2004 to that in 2006?
Your answer should be compact. 0.32. What is the ratio of the Aid flow (current US$) in Honduras in 2004 to that in 2006?
Ensure brevity in your answer.  0.53. What is the ratio of the Aid flow (current US$) of St. Lucia in 2004 to that in 2006?
Ensure brevity in your answer.  0.43. What is the ratio of the Aid flow (current US$) in Congo (Democratic) in 2004 to that in 2007?
Offer a very short reply. 0.26. What is the ratio of the Aid flow (current US$) of Honduras in 2004 to that in 2007?
Offer a terse response. 0.54. What is the ratio of the Aid flow (current US$) of Jordan in 2004 to that in 2007?
Your response must be concise. 0.07. What is the ratio of the Aid flow (current US$) in Congo (Democratic) in 2004 to that in 2008?
Give a very brief answer. 0.23. What is the ratio of the Aid flow (current US$) of Honduras in 2004 to that in 2008?
Your response must be concise. 0.6. What is the ratio of the Aid flow (current US$) in Jordan in 2004 to that in 2008?
Your answer should be very brief. 0.07. What is the ratio of the Aid flow (current US$) of St. Lucia in 2004 to that in 2008?
Provide a succinct answer. 9. What is the ratio of the Aid flow (current US$) of Congo (Democratic) in 2004 to that in 2009?
Give a very brief answer. 0.44. What is the ratio of the Aid flow (current US$) of Honduras in 2004 to that in 2009?
Offer a terse response. 0.76. What is the ratio of the Aid flow (current US$) of Jordan in 2004 to that in 2009?
Provide a short and direct response. 0.1. What is the ratio of the Aid flow (current US$) of St. Lucia in 2004 to that in 2009?
Provide a succinct answer. 1.5. What is the ratio of the Aid flow (current US$) of Congo (Democratic) in 2004 to that in 2010?
Offer a very short reply. 0.46. What is the ratio of the Aid flow (current US$) of Honduras in 2004 to that in 2010?
Provide a succinct answer. 1.55. What is the ratio of the Aid flow (current US$) in Congo (Democratic) in 2005 to that in 2006?
Give a very brief answer. 0.46. What is the ratio of the Aid flow (current US$) of Honduras in 2005 to that in 2006?
Make the answer very short. 0.56. What is the ratio of the Aid flow (current US$) in Jordan in 2005 to that in 2006?
Make the answer very short. 0.12. What is the ratio of the Aid flow (current US$) of St. Lucia in 2005 to that in 2006?
Ensure brevity in your answer.  0.48. What is the ratio of the Aid flow (current US$) of Congo (Democratic) in 2005 to that in 2007?
Offer a very short reply. 0.38. What is the ratio of the Aid flow (current US$) of Honduras in 2005 to that in 2007?
Your answer should be very brief. 0.57. What is the ratio of the Aid flow (current US$) of Jordan in 2005 to that in 2007?
Provide a short and direct response. 0.21. What is the ratio of the Aid flow (current US$) in St. Lucia in 2005 to that in 2007?
Offer a terse response. 1.11. What is the ratio of the Aid flow (current US$) in Congo (Democratic) in 2005 to that in 2008?
Keep it short and to the point. 0.33. What is the ratio of the Aid flow (current US$) in Honduras in 2005 to that in 2008?
Keep it short and to the point. 0.63. What is the ratio of the Aid flow (current US$) in Jordan in 2005 to that in 2008?
Make the answer very short. 0.21. What is the ratio of the Aid flow (current US$) in Congo (Democratic) in 2005 to that in 2009?
Keep it short and to the point. 0.63. What is the ratio of the Aid flow (current US$) in Honduras in 2005 to that in 2009?
Make the answer very short. 0.8. What is the ratio of the Aid flow (current US$) of Jordan in 2005 to that in 2009?
Your answer should be very brief. 0.3. What is the ratio of the Aid flow (current US$) in Congo (Democratic) in 2005 to that in 2010?
Offer a terse response. 0.67. What is the ratio of the Aid flow (current US$) of Honduras in 2005 to that in 2010?
Make the answer very short. 1.63. What is the ratio of the Aid flow (current US$) in Congo (Democratic) in 2006 to that in 2007?
Your answer should be very brief. 0.82. What is the ratio of the Aid flow (current US$) of Honduras in 2006 to that in 2007?
Your response must be concise. 1.02. What is the ratio of the Aid flow (current US$) in Jordan in 2006 to that in 2007?
Your answer should be compact. 1.79. What is the ratio of the Aid flow (current US$) of St. Lucia in 2006 to that in 2007?
Offer a terse response. 2.33. What is the ratio of the Aid flow (current US$) of Congo (Democratic) in 2006 to that in 2008?
Your answer should be very brief. 0.72. What is the ratio of the Aid flow (current US$) of Honduras in 2006 to that in 2008?
Ensure brevity in your answer.  1.13. What is the ratio of the Aid flow (current US$) in Jordan in 2006 to that in 2008?
Your answer should be compact. 1.79. What is the ratio of the Aid flow (current US$) of St. Lucia in 2006 to that in 2008?
Provide a succinct answer. 21. What is the ratio of the Aid flow (current US$) of Congo (Democratic) in 2006 to that in 2009?
Offer a very short reply. 1.37. What is the ratio of the Aid flow (current US$) of Honduras in 2006 to that in 2009?
Provide a short and direct response. 1.43. What is the ratio of the Aid flow (current US$) of Jordan in 2006 to that in 2009?
Your answer should be very brief. 2.5. What is the ratio of the Aid flow (current US$) in St. Lucia in 2006 to that in 2009?
Offer a very short reply. 3.5. What is the ratio of the Aid flow (current US$) in Congo (Democratic) in 2006 to that in 2010?
Your answer should be very brief. 1.46. What is the ratio of the Aid flow (current US$) in Honduras in 2006 to that in 2010?
Offer a terse response. 2.91. What is the ratio of the Aid flow (current US$) of Jordan in 2006 to that in 2010?
Your answer should be very brief. 6.25. What is the ratio of the Aid flow (current US$) of St. Lucia in 2006 to that in 2010?
Provide a succinct answer. 4.2. What is the ratio of the Aid flow (current US$) of Congo (Democratic) in 2007 to that in 2008?
Provide a succinct answer. 0.88. What is the ratio of the Aid flow (current US$) in Honduras in 2007 to that in 2008?
Provide a short and direct response. 1.11. What is the ratio of the Aid flow (current US$) of St. Lucia in 2007 to that in 2008?
Your response must be concise. 9. What is the ratio of the Aid flow (current US$) in Congo (Democratic) in 2007 to that in 2009?
Your answer should be compact. 1.68. What is the ratio of the Aid flow (current US$) in Honduras in 2007 to that in 2009?
Provide a succinct answer. 1.41. What is the ratio of the Aid flow (current US$) of Congo (Democratic) in 2007 to that in 2010?
Ensure brevity in your answer.  1.78. What is the ratio of the Aid flow (current US$) of Honduras in 2007 to that in 2010?
Provide a short and direct response. 2.87. What is the ratio of the Aid flow (current US$) of Jordan in 2007 to that in 2010?
Ensure brevity in your answer.  3.5. What is the ratio of the Aid flow (current US$) of Congo (Democratic) in 2008 to that in 2009?
Make the answer very short. 1.91. What is the ratio of the Aid flow (current US$) of Honduras in 2008 to that in 2009?
Provide a short and direct response. 1.26. What is the ratio of the Aid flow (current US$) of Jordan in 2008 to that in 2009?
Give a very brief answer. 1.4. What is the ratio of the Aid flow (current US$) in Congo (Democratic) in 2008 to that in 2010?
Keep it short and to the point. 2.03. What is the ratio of the Aid flow (current US$) in Honduras in 2008 to that in 2010?
Your answer should be very brief. 2.57. What is the ratio of the Aid flow (current US$) of Congo (Democratic) in 2009 to that in 2010?
Provide a short and direct response. 1.06. What is the ratio of the Aid flow (current US$) of Honduras in 2009 to that in 2010?
Keep it short and to the point. 2.04. What is the ratio of the Aid flow (current US$) of Jordan in 2009 to that in 2010?
Provide a succinct answer. 2.5. What is the difference between the highest and the second highest Aid flow (current US$) of Congo (Democratic)?
Offer a terse response. 2.18e+06. What is the difference between the highest and the second highest Aid flow (current US$) of Honduras?
Keep it short and to the point. 9.00e+04. What is the difference between the highest and the second highest Aid flow (current US$) of Jordan?
Provide a succinct answer. 1.10e+05. What is the difference between the highest and the second highest Aid flow (current US$) of St. Lucia?
Provide a short and direct response. 1.10e+05. What is the difference between the highest and the lowest Aid flow (current US$) in Congo (Democratic)?
Your answer should be very brief. 1.38e+07. What is the difference between the highest and the lowest Aid flow (current US$) in Honduras?
Provide a short and direct response. 3.77e+06. What is the difference between the highest and the lowest Aid flow (current US$) of St. Lucia?
Give a very brief answer. 2.00e+05. 